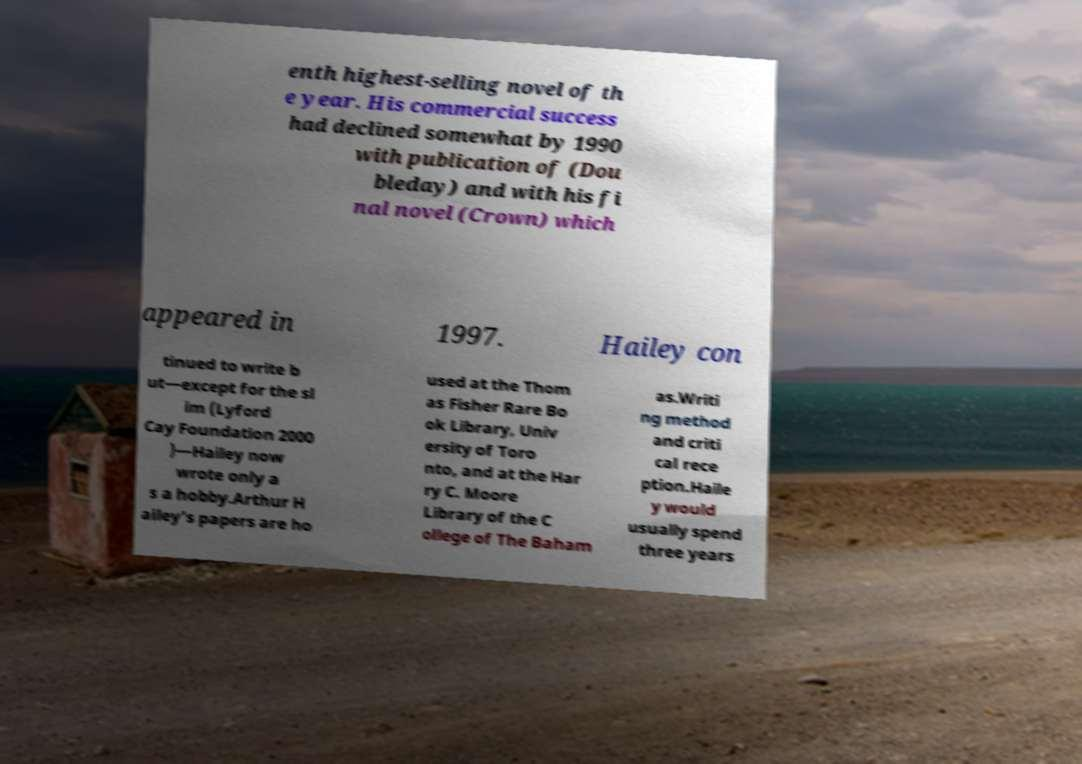What messages or text are displayed in this image? I need them in a readable, typed format. enth highest-selling novel of th e year. His commercial success had declined somewhat by 1990 with publication of (Dou bleday) and with his fi nal novel (Crown) which appeared in 1997. Hailey con tinued to write b ut—except for the sl im (Lyford Cay Foundation 2000 )—Hailey now wrote only a s a hobby.Arthur H ailey's papers are ho used at the Thom as Fisher Rare Bo ok Library, Univ ersity of Toro nto, and at the Har ry C. Moore Library of the C ollege of The Baham as.Writi ng method and criti cal rece ption.Haile y would usually spend three years 